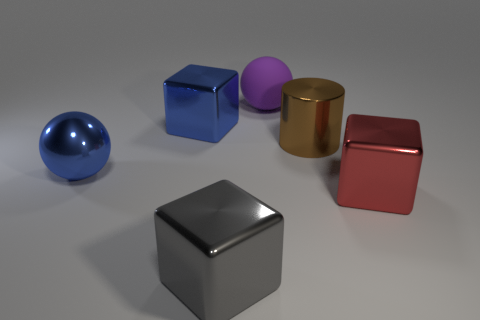Add 4 brown shiny things. How many objects exist? 10 Subtract all cylinders. How many objects are left? 5 Add 1 blue balls. How many blue balls are left? 2 Add 1 large brown objects. How many large brown objects exist? 2 Subtract 0 green balls. How many objects are left? 6 Subtract all brown balls. Subtract all big purple spheres. How many objects are left? 5 